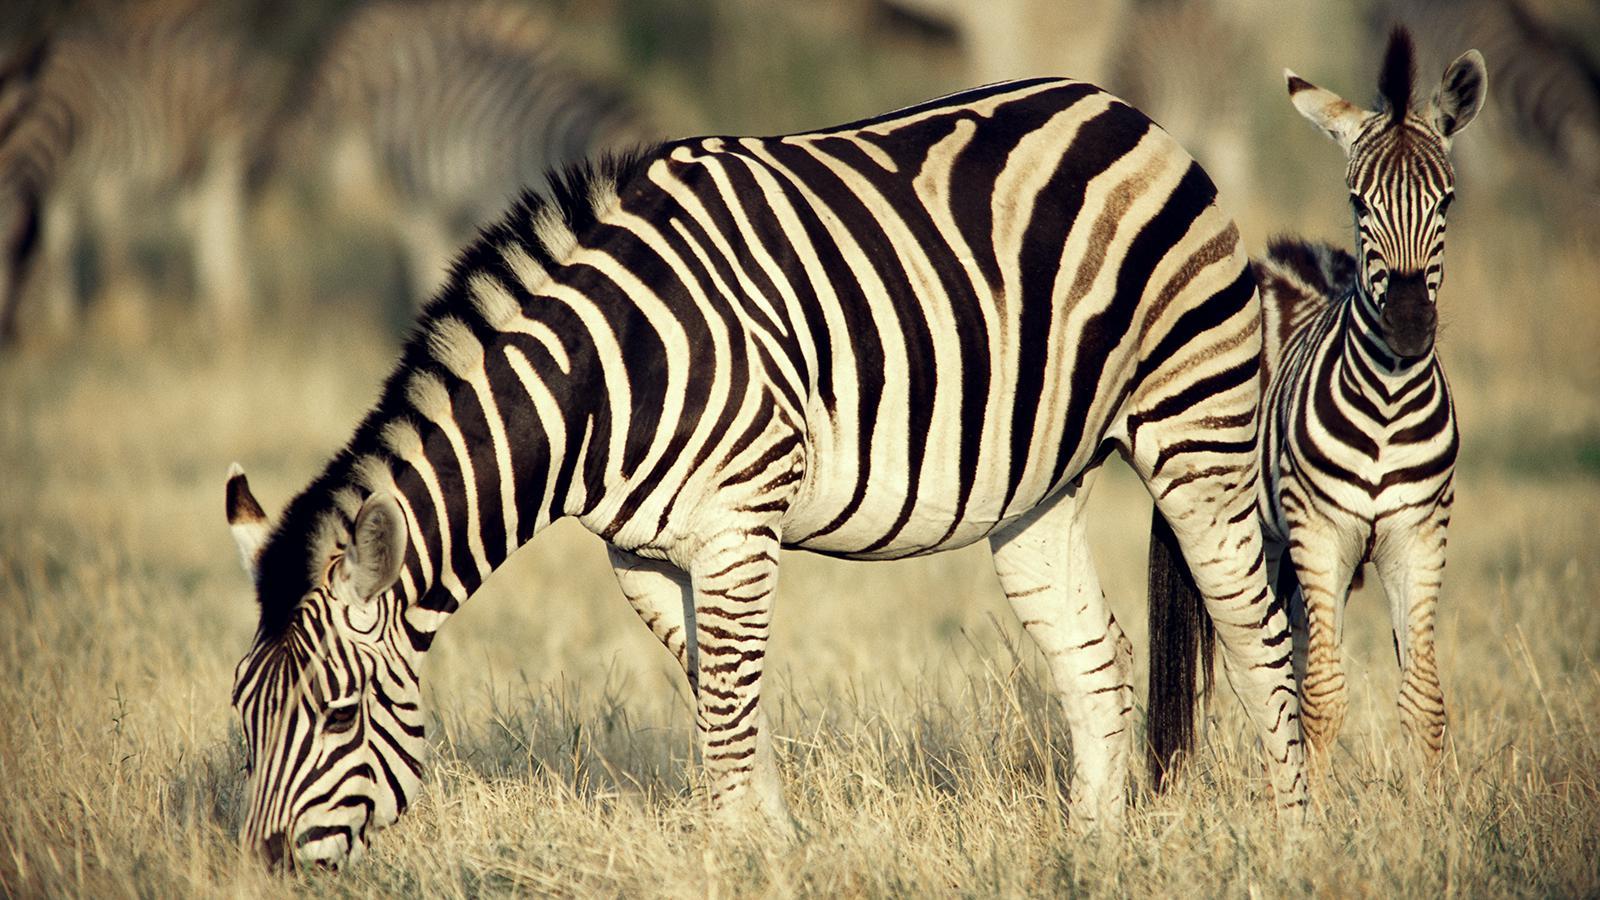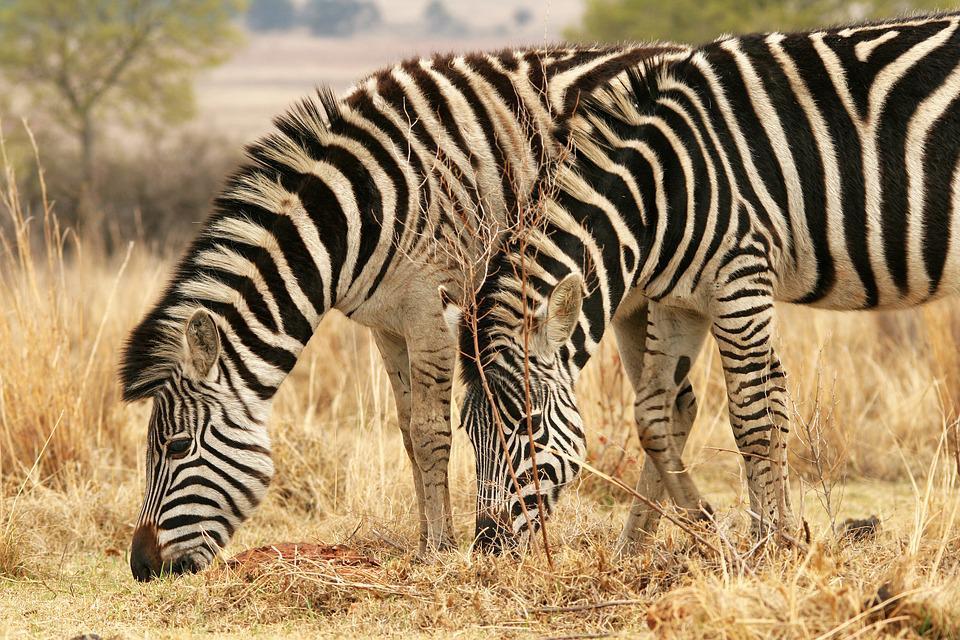The first image is the image on the left, the second image is the image on the right. Considering the images on both sides, is "Two zebras are standing in the grass in at least one of the images." valid? Answer yes or no. Yes. The first image is the image on the left, the second image is the image on the right. Considering the images on both sides, is "The left image shows a standing zebra colt with upright head next to a standing adult zebra with its head lowered to graze." valid? Answer yes or no. Yes. 